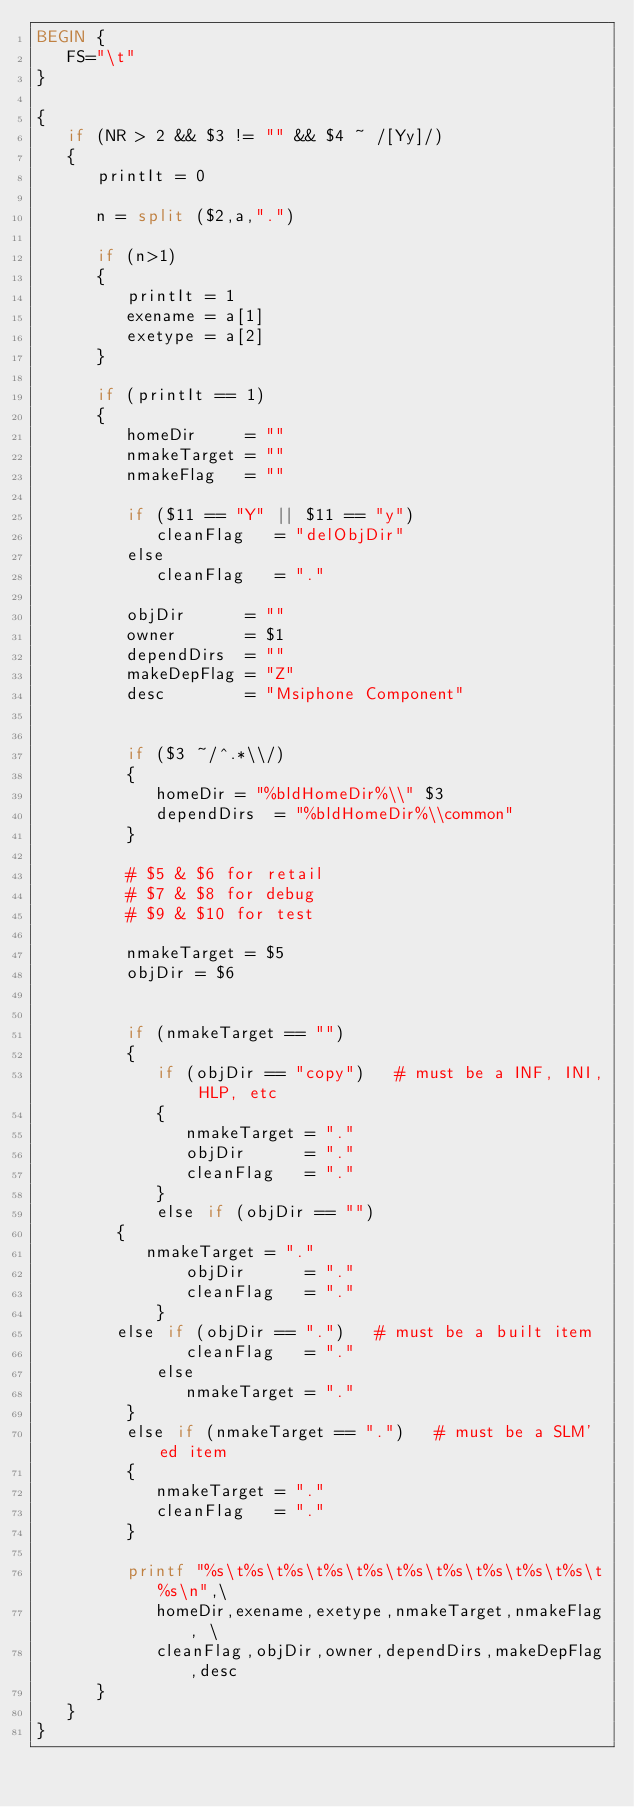<code> <loc_0><loc_0><loc_500><loc_500><_Awk_>BEGIN {
   FS="\t"
}

{
   if (NR > 2 && $3 != "" && $4 ~ /[Yy]/)
   {
      printIt = 0
   
      n = split ($2,a,".")
   
      if (n>1)
      {
         printIt = 1
         exename = a[1]
         exetype = a[2]
      }
   
      if (printIt == 1)
      {
         homeDir     = ""
         nmakeTarget = ""
         nmakeFlag   = ""

         if ($11 == "Y" || $11 == "y")
            cleanFlag   = "delObjDir"
         else
            cleanFlag   = "."

         objDir      = ""
         owner       = $1
         dependDirs  = ""
         makeDepFlag = "Z"
         desc        = "Msiphone Component"


         if ($3 ~/^.*\\/)
         {
            homeDir = "%bldHomeDir%\\" $3
            dependDirs  = "%bldHomeDir%\\common"
         }
   
         # $5 & $6 for retail
         # $7 & $8 for debug
         # $9 & $10 for test

         nmakeTarget = $5
         objDir = $6


         if (nmakeTarget == "")
         {
            if (objDir == "copy")   # must be a INF, INI, HLP, etc
            {
               nmakeTarget = "."
               objDir      = "."
               cleanFlag   = "."
            }
            else if (objDir == "")
	    {
	       nmakeTarget = "."
               objDir      = "."
               cleanFlag   = "."
            }
	    else if (objDir == ".")   # must be a built item
               cleanFlag   = "."
            else
               nmakeTarget = "."
         }
         else if (nmakeTarget == ".")   # must be a SLM'ed item
         {
            nmakeTarget = "."
            cleanFlag   = "."
         }

         printf "%s\t%s\t%s\t%s\t%s\t%s\t%s\t%s\t%s\t%s\t%s\n",\
            homeDir,exename,exetype,nmakeTarget,nmakeFlag, \
            cleanFlag,objDir,owner,dependDirs,makeDepFlag,desc
      }
   }
}
</code> 